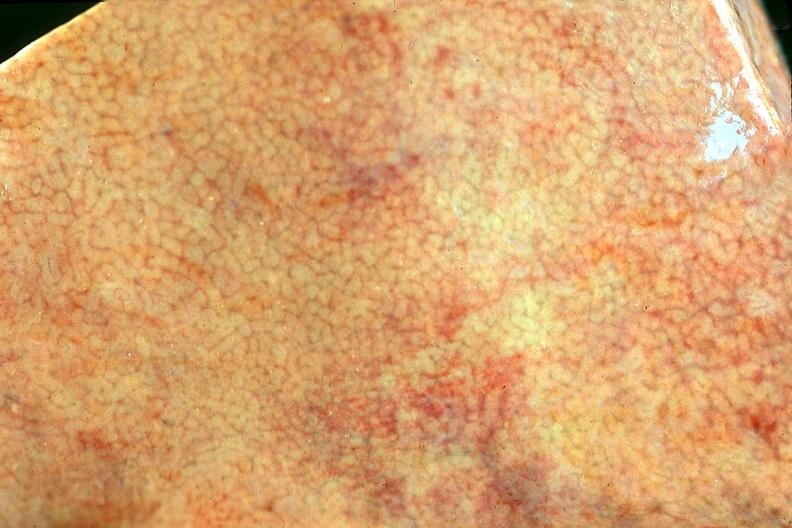s hepatobiliary present?
Answer the question using a single word or phrase. Yes 